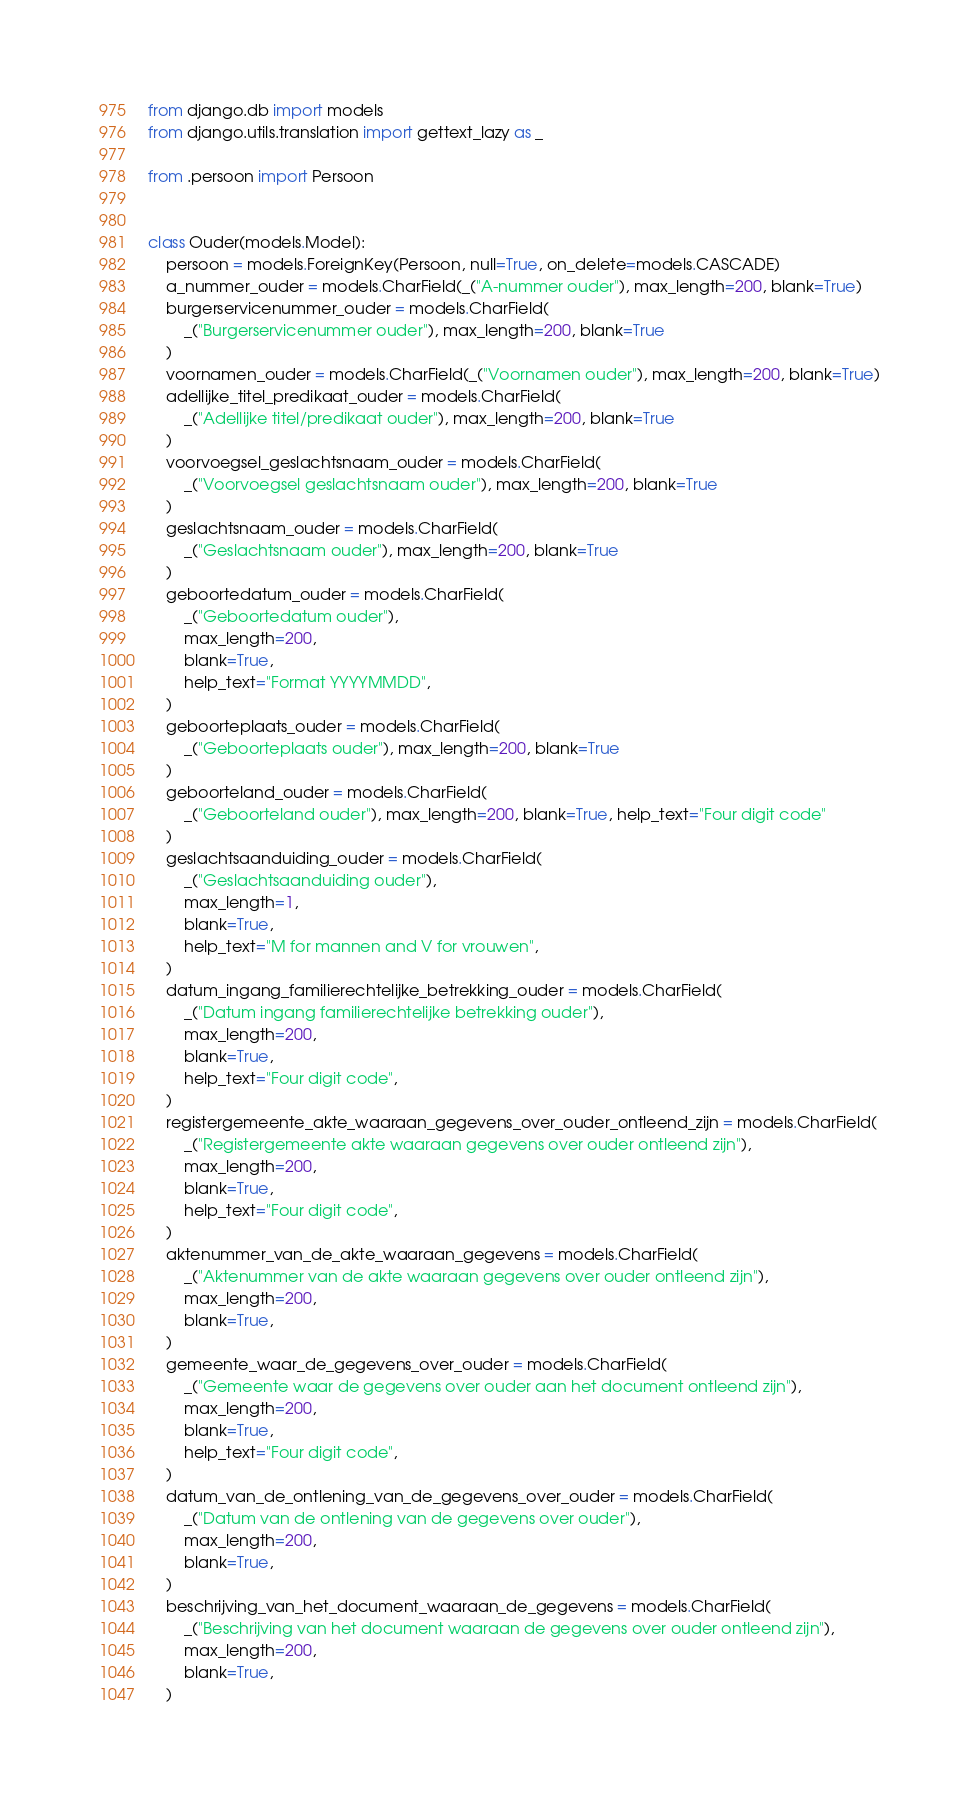Convert code to text. <code><loc_0><loc_0><loc_500><loc_500><_Python_>from django.db import models
from django.utils.translation import gettext_lazy as _

from .persoon import Persoon


class Ouder(models.Model):
    persoon = models.ForeignKey(Persoon, null=True, on_delete=models.CASCADE)
    a_nummer_ouder = models.CharField(_("A-nummer ouder"), max_length=200, blank=True)
    burgerservicenummer_ouder = models.CharField(
        _("Burgerservicenummer ouder"), max_length=200, blank=True
    )
    voornamen_ouder = models.CharField(_("Voornamen ouder"), max_length=200, blank=True)
    adellijke_titel_predikaat_ouder = models.CharField(
        _("Adellijke titel/predikaat ouder"), max_length=200, blank=True
    )
    voorvoegsel_geslachtsnaam_ouder = models.CharField(
        _("Voorvoegsel geslachtsnaam ouder"), max_length=200, blank=True
    )
    geslachtsnaam_ouder = models.CharField(
        _("Geslachtsnaam ouder"), max_length=200, blank=True
    )
    geboortedatum_ouder = models.CharField(
        _("Geboortedatum ouder"),
        max_length=200,
        blank=True,
        help_text="Format YYYYMMDD",
    )
    geboorteplaats_ouder = models.CharField(
        _("Geboorteplaats ouder"), max_length=200, blank=True
    )
    geboorteland_ouder = models.CharField(
        _("Geboorteland ouder"), max_length=200, blank=True, help_text="Four digit code"
    )
    geslachtsaanduiding_ouder = models.CharField(
        _("Geslachtsaanduiding ouder"),
        max_length=1,
        blank=True,
        help_text="M for mannen and V for vrouwen",
    )
    datum_ingang_familierechtelijke_betrekking_ouder = models.CharField(
        _("Datum ingang familierechtelijke betrekking ouder"),
        max_length=200,
        blank=True,
        help_text="Four digit code",
    )
    registergemeente_akte_waaraan_gegevens_over_ouder_ontleend_zijn = models.CharField(
        _("Registergemeente akte waaraan gegevens over ouder ontleend zijn"),
        max_length=200,
        blank=True,
        help_text="Four digit code",
    )
    aktenummer_van_de_akte_waaraan_gegevens = models.CharField(
        _("Aktenummer van de akte waaraan gegevens over ouder ontleend zijn"),
        max_length=200,
        blank=True,
    )
    gemeente_waar_de_gegevens_over_ouder = models.CharField(
        _("Gemeente waar de gegevens over ouder aan het document ontleend zijn"),
        max_length=200,
        blank=True,
        help_text="Four digit code",
    )
    datum_van_de_ontlening_van_de_gegevens_over_ouder = models.CharField(
        _("Datum van de ontlening van de gegevens over ouder"),
        max_length=200,
        blank=True,
    )
    beschrijving_van_het_document_waaraan_de_gegevens = models.CharField(
        _("Beschrijving van het document waaraan de gegevens over ouder ontleend zijn"),
        max_length=200,
        blank=True,
    )</code> 